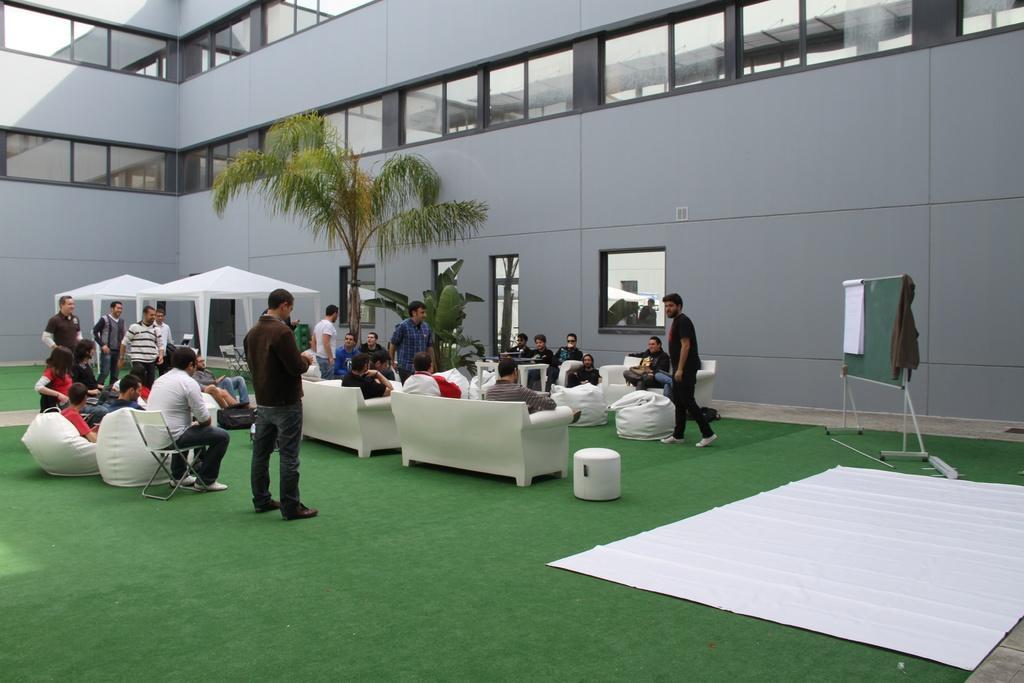In one or two sentences, can you explain what this image depicts? In this image we can see the buildings with the windows. We can also see the trees and also the tents for shelter. We can see the bean bags, chairs and also the sofas. We can also see the people standing and a few people are sitting. We can see the board, white color mat and also the green color mats on the surface. 